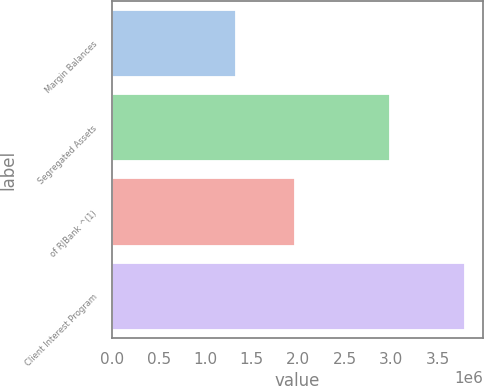Convert chart. <chart><loc_0><loc_0><loc_500><loc_500><bar_chart><fcel>Margin Balances<fcel>Segregated Assets<fcel>of RJBank ^(1)<fcel>Client Interest Program<nl><fcel>1.32712e+06<fcel>2.98385e+06<fcel>1.96722e+06<fcel>3.79357e+06<nl></chart> 